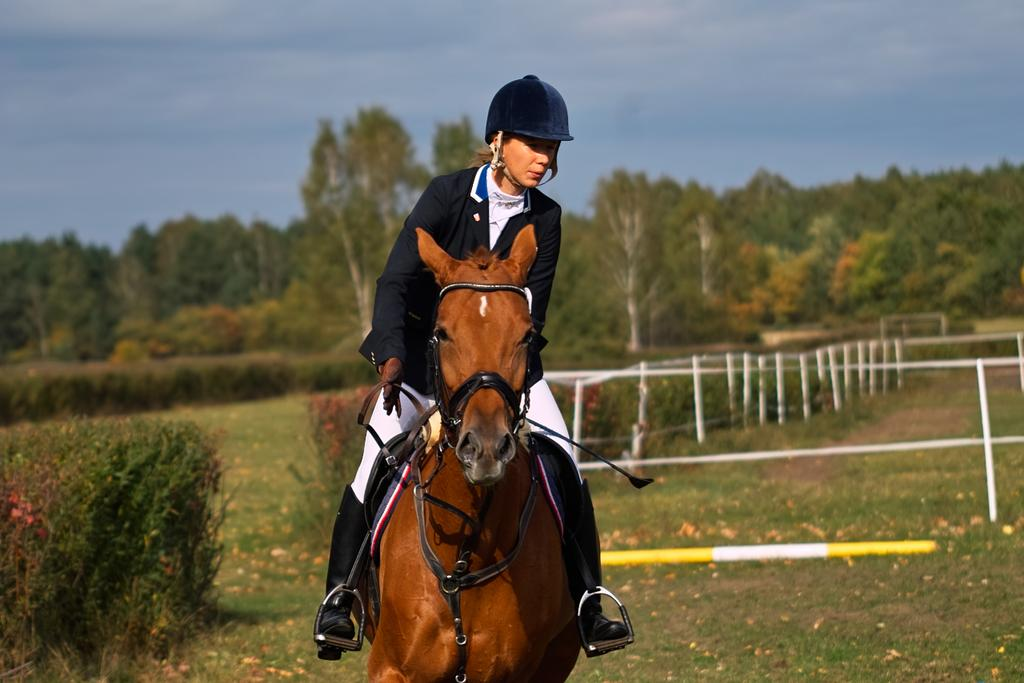Who is the main subject in the image? There is a girl in the image. What is the girl wearing? The girl is wearing a blue coat and a helmet. What is the girl doing in the image? The girl is riding a brown horse. What can be seen in the background of the image? There is a white color fencing grill and many trees in the background. What type of church can be seen in the background of the image? There is no church present in the background of the image; it features a white color fencing grill and trees. Can you tell me how many wrens are sitting on the girl's shoulder in the image? There are no wrens present in the image; the girl is riding a brown horse and wearing a blue coat and a helmet. 